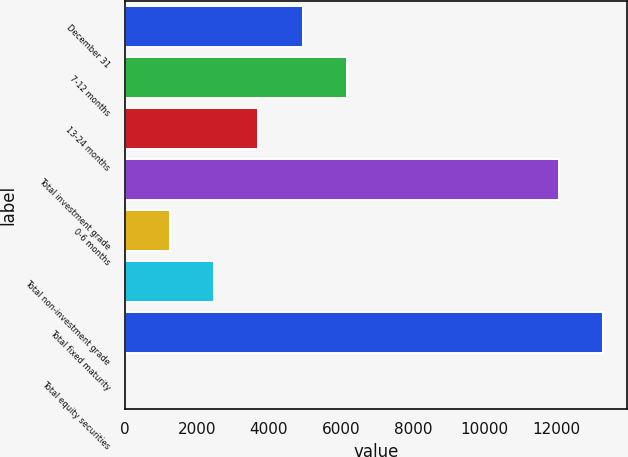<chart> <loc_0><loc_0><loc_500><loc_500><bar_chart><fcel>December 31<fcel>7-12 months<fcel>13-24 months<fcel>Total investment grade<fcel>0-6 months<fcel>Total non-investment grade<fcel>Total fixed maturity<fcel>Total equity securities<nl><fcel>4937.68<fcel>6169.85<fcel>3705.51<fcel>12053.7<fcel>1241.17<fcel>2473.34<fcel>13285.9<fcel>9<nl></chart> 